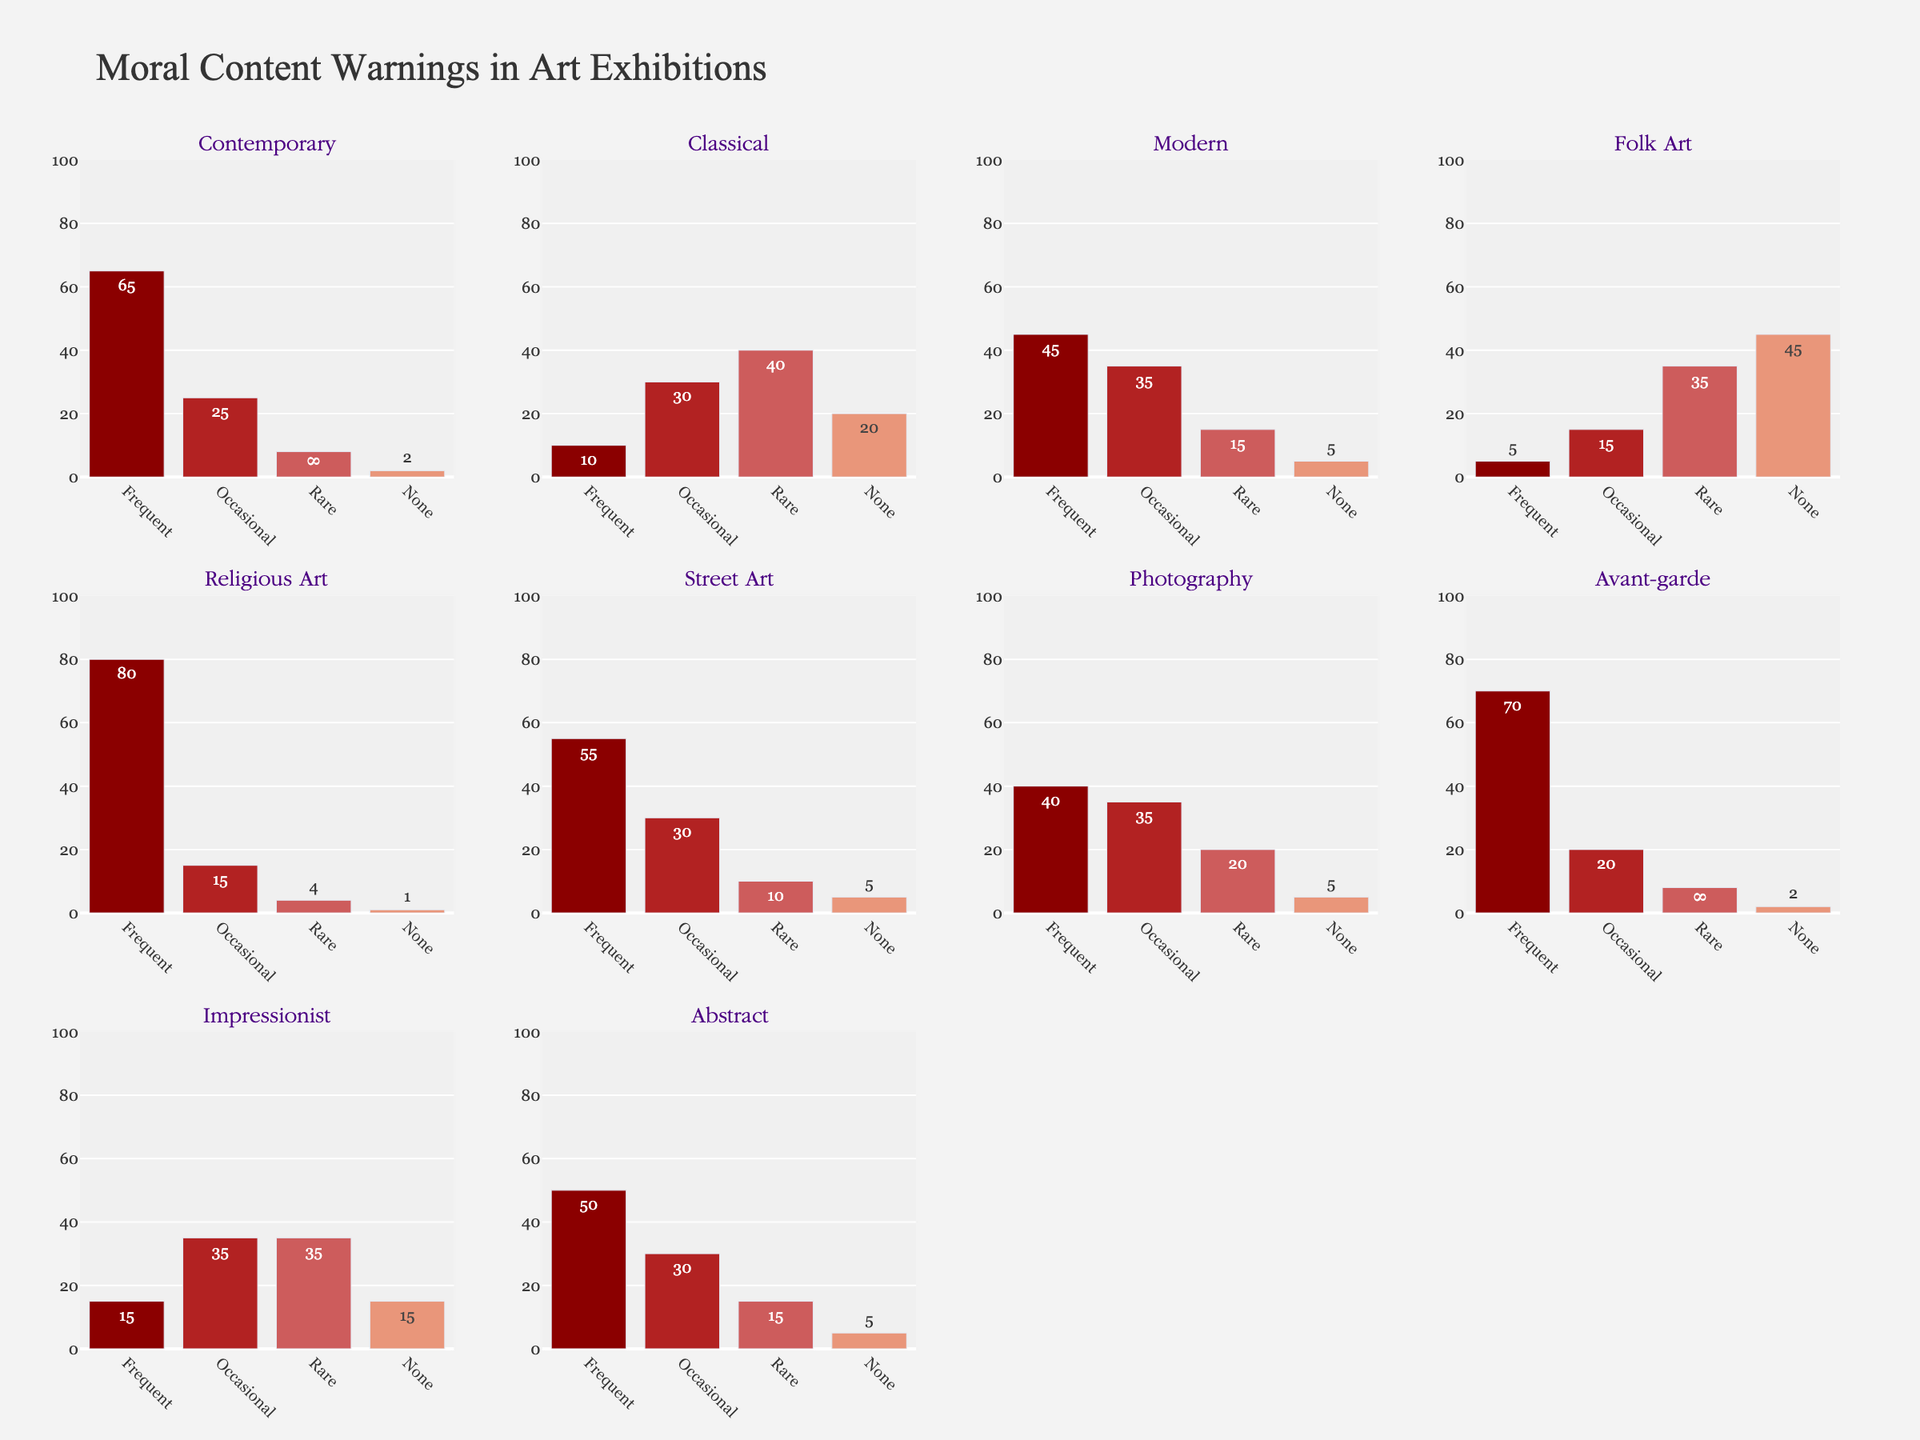What's the overall title of the figure? The overall title is usually located at the top-center of the figure and provides a summary of the content being presented. In this case, it's "Moral Content Warnings in Art Exhibitions".
Answer: Moral Content Warnings in Art Exhibitions Which gallery type has the highest count of "Frequent" moral content warnings? To find the gallery type with the highest count of "Frequent" warnings, look at the bar labeled "Frequent" and identify the gallery type with the tallest bar. In this case, "Religious Art" in Vatican City has the tallest bar.
Answer: Religious Art Which gallery type has the lowest count of "None" moral content warnings? To identify the gallery type with the lowest count of "None" warnings, find the shortest bar for "None" across all subplots. Here, "Religious Art" in Vatican City has the shortest bar in the "None" category.
Answer: Religious Art How many gallery types have more than 50 "Frequent" moral content warnings? Count the number of gallery types where the bar for "Frequent" exceeds 50. In this case, "Contemporary" (New York), "Religious Art" (Vatican City), "Avant-garde" (Moscow), and "Street Art" (Berlin) satisfy this condition.
Answer: 4 What is the sum of "Frequent" moral content warnings for "Photography" and "Modern" gallery types? To find the sum, add the "Frequent" counts for "Photography" in Tokyo and "Modern" in London. "Photography" has 40 and "Modern" has 45, resulting in 40 + 45 = 85.
Answer: 85 Which gallery type in Europe's capital cities has the most "Occasional" moral content warnings? Consider only gallery types in European capitals (Paris, London, Berlin, Amsterdam, Vatican City, Moscow). Compare their "Occasional" warnings. "Classical" in Paris has 30, "Modern" in London has 35, "Street Art" in Berlin has 30, "Impressionist" in Amsterdam has 35, "Religious Art" in Vatican City has 15, and "Avant-garde" in Moscow has 20. Thus, either "Modern" in London or "Impressionist" in Amsterdam has the highest at 35.
Answer: Modern (London) or Impressionist (Amsterdam) What's the average count of "Rare" moral content warnings across all gallery types? To find the average, sum the "Rare" counts of all gallery types and divide by the number of gallery types. The counts are 8, 40, 15, 35, 4, 10, 20, 8, 35, 15, totaling 190. There are 10 gallery types, so the average is 190/10 = 19.
Answer: 19 Is there any gallery type where "None" moral content warnings are greater than "Rare" moral content warnings? Compare the "None" and "Rare" bars for each gallery type. If the "None" bar is taller than the "Rare" bar, then it satisfies this condition. "Folk Art" in Santa Fe has 45 "None" and 35 "Rare", meeting the criteria.
Answer: Yes Which gallery type, if any, shows an equal number of "Occasional" and "Rare" moral content warnings? Find a gallery type where the "Occasional" bar equals the "Rare" bar. "Impressionist" in Amsterdam has 35 for both "Occasional" and "Rare".
Answer: Impressionist 